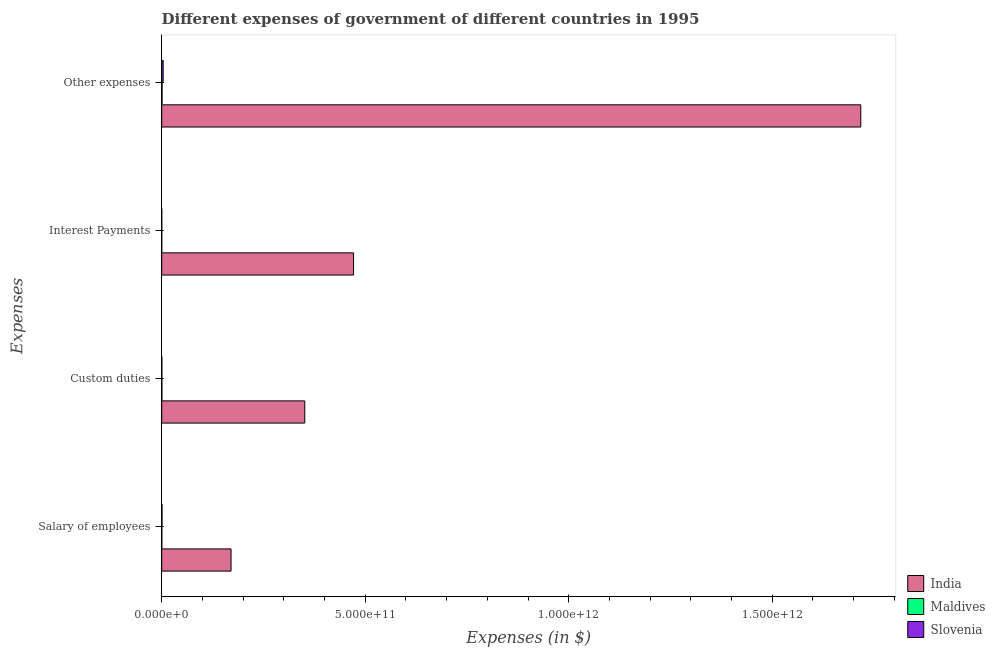How many different coloured bars are there?
Make the answer very short. 3. Are the number of bars on each tick of the Y-axis equal?
Offer a very short reply. Yes. How many bars are there on the 2nd tick from the top?
Your response must be concise. 3. How many bars are there on the 1st tick from the bottom?
Ensure brevity in your answer.  3. What is the label of the 3rd group of bars from the top?
Provide a succinct answer. Custom duties. What is the amount spent on other expenses in Maldives?
Keep it short and to the point. 8.78e+08. Across all countries, what is the maximum amount spent on interest payments?
Make the answer very short. 4.71e+11. Across all countries, what is the minimum amount spent on salary of employees?
Provide a succinct answer. 2.32e+08. In which country was the amount spent on interest payments minimum?
Give a very brief answer. Maldives. What is the total amount spent on other expenses in the graph?
Your answer should be very brief. 1.72e+12. What is the difference between the amount spent on interest payments in Slovenia and that in India?
Offer a very short reply. -4.71e+11. What is the difference between the amount spent on other expenses in India and the amount spent on interest payments in Maldives?
Provide a succinct answer. 1.72e+12. What is the average amount spent on custom duties per country?
Provide a short and direct response. 1.17e+11. What is the difference between the amount spent on salary of employees and amount spent on custom duties in Slovenia?
Your answer should be very brief. 4.04e+08. In how many countries, is the amount spent on other expenses greater than 1300000000000 $?
Provide a succinct answer. 1. What is the ratio of the amount spent on other expenses in Maldives to that in India?
Provide a short and direct response. 0. What is the difference between the highest and the second highest amount spent on salary of employees?
Give a very brief answer. 1.70e+11. What is the difference between the highest and the lowest amount spent on salary of employees?
Give a very brief answer. 1.70e+11. Is the sum of the amount spent on salary of employees in India and Slovenia greater than the maximum amount spent on interest payments across all countries?
Offer a very short reply. No. What does the 1st bar from the top in Salary of employees represents?
Make the answer very short. Slovenia. What does the 1st bar from the bottom in Custom duties represents?
Your answer should be compact. India. Is it the case that in every country, the sum of the amount spent on salary of employees and amount spent on custom duties is greater than the amount spent on interest payments?
Provide a succinct answer. Yes. How many bars are there?
Your answer should be very brief. 12. Are all the bars in the graph horizontal?
Offer a very short reply. Yes. What is the difference between two consecutive major ticks on the X-axis?
Your response must be concise. 5.00e+11. Does the graph contain any zero values?
Offer a terse response. No. Where does the legend appear in the graph?
Make the answer very short. Bottom right. How are the legend labels stacked?
Offer a terse response. Vertical. What is the title of the graph?
Keep it short and to the point. Different expenses of government of different countries in 1995. What is the label or title of the X-axis?
Make the answer very short. Expenses (in $). What is the label or title of the Y-axis?
Ensure brevity in your answer.  Expenses. What is the Expenses (in $) in India in Salary of employees?
Make the answer very short. 1.70e+11. What is the Expenses (in $) of Maldives in Salary of employees?
Your response must be concise. 2.32e+08. What is the Expenses (in $) in Slovenia in Salary of employees?
Provide a succinct answer. 7.30e+08. What is the Expenses (in $) in India in Custom duties?
Keep it short and to the point. 3.51e+11. What is the Expenses (in $) in Maldives in Custom duties?
Offer a terse response. 4.10e+08. What is the Expenses (in $) in Slovenia in Custom duties?
Make the answer very short. 3.26e+08. What is the Expenses (in $) in India in Interest Payments?
Your answer should be very brief. 4.71e+11. What is the Expenses (in $) in Maldives in Interest Payments?
Make the answer very short. 7.65e+07. What is the Expenses (in $) of Slovenia in Interest Payments?
Your answer should be compact. 1.04e+08. What is the Expenses (in $) of India in Other expenses?
Ensure brevity in your answer.  1.72e+12. What is the Expenses (in $) in Maldives in Other expenses?
Your response must be concise. 8.78e+08. What is the Expenses (in $) of Slovenia in Other expenses?
Provide a succinct answer. 3.53e+09. Across all Expenses, what is the maximum Expenses (in $) of India?
Give a very brief answer. 1.72e+12. Across all Expenses, what is the maximum Expenses (in $) of Maldives?
Make the answer very short. 8.78e+08. Across all Expenses, what is the maximum Expenses (in $) of Slovenia?
Provide a short and direct response. 3.53e+09. Across all Expenses, what is the minimum Expenses (in $) of India?
Give a very brief answer. 1.70e+11. Across all Expenses, what is the minimum Expenses (in $) of Maldives?
Give a very brief answer. 7.65e+07. Across all Expenses, what is the minimum Expenses (in $) of Slovenia?
Provide a short and direct response. 1.04e+08. What is the total Expenses (in $) of India in the graph?
Your answer should be compact. 2.71e+12. What is the total Expenses (in $) of Maldives in the graph?
Ensure brevity in your answer.  1.60e+09. What is the total Expenses (in $) in Slovenia in the graph?
Give a very brief answer. 4.69e+09. What is the difference between the Expenses (in $) of India in Salary of employees and that in Custom duties?
Keep it short and to the point. -1.81e+11. What is the difference between the Expenses (in $) in Maldives in Salary of employees and that in Custom duties?
Ensure brevity in your answer.  -1.78e+08. What is the difference between the Expenses (in $) of Slovenia in Salary of employees and that in Custom duties?
Make the answer very short. 4.04e+08. What is the difference between the Expenses (in $) in India in Salary of employees and that in Interest Payments?
Give a very brief answer. -3.01e+11. What is the difference between the Expenses (in $) in Maldives in Salary of employees and that in Interest Payments?
Offer a terse response. 1.56e+08. What is the difference between the Expenses (in $) of Slovenia in Salary of employees and that in Interest Payments?
Provide a short and direct response. 6.26e+08. What is the difference between the Expenses (in $) in India in Salary of employees and that in Other expenses?
Make the answer very short. -1.55e+12. What is the difference between the Expenses (in $) in Maldives in Salary of employees and that in Other expenses?
Give a very brief answer. -6.46e+08. What is the difference between the Expenses (in $) in Slovenia in Salary of employees and that in Other expenses?
Your response must be concise. -2.80e+09. What is the difference between the Expenses (in $) of India in Custom duties and that in Interest Payments?
Keep it short and to the point. -1.20e+11. What is the difference between the Expenses (in $) in Maldives in Custom duties and that in Interest Payments?
Offer a terse response. 3.34e+08. What is the difference between the Expenses (in $) in Slovenia in Custom duties and that in Interest Payments?
Your answer should be compact. 2.22e+08. What is the difference between the Expenses (in $) of India in Custom duties and that in Other expenses?
Offer a very short reply. -1.37e+12. What is the difference between the Expenses (in $) of Maldives in Custom duties and that in Other expenses?
Your answer should be very brief. -4.68e+08. What is the difference between the Expenses (in $) in Slovenia in Custom duties and that in Other expenses?
Make the answer very short. -3.21e+09. What is the difference between the Expenses (in $) in India in Interest Payments and that in Other expenses?
Give a very brief answer. -1.25e+12. What is the difference between the Expenses (in $) of Maldives in Interest Payments and that in Other expenses?
Give a very brief answer. -8.02e+08. What is the difference between the Expenses (in $) in Slovenia in Interest Payments and that in Other expenses?
Give a very brief answer. -3.43e+09. What is the difference between the Expenses (in $) in India in Salary of employees and the Expenses (in $) in Maldives in Custom duties?
Ensure brevity in your answer.  1.70e+11. What is the difference between the Expenses (in $) of India in Salary of employees and the Expenses (in $) of Slovenia in Custom duties?
Offer a very short reply. 1.70e+11. What is the difference between the Expenses (in $) in Maldives in Salary of employees and the Expenses (in $) in Slovenia in Custom duties?
Your answer should be very brief. -9.41e+07. What is the difference between the Expenses (in $) in India in Salary of employees and the Expenses (in $) in Maldives in Interest Payments?
Give a very brief answer. 1.70e+11. What is the difference between the Expenses (in $) of India in Salary of employees and the Expenses (in $) of Slovenia in Interest Payments?
Make the answer very short. 1.70e+11. What is the difference between the Expenses (in $) of Maldives in Salary of employees and the Expenses (in $) of Slovenia in Interest Payments?
Your response must be concise. 1.28e+08. What is the difference between the Expenses (in $) in India in Salary of employees and the Expenses (in $) in Maldives in Other expenses?
Your response must be concise. 1.69e+11. What is the difference between the Expenses (in $) in India in Salary of employees and the Expenses (in $) in Slovenia in Other expenses?
Give a very brief answer. 1.67e+11. What is the difference between the Expenses (in $) in Maldives in Salary of employees and the Expenses (in $) in Slovenia in Other expenses?
Offer a very short reply. -3.30e+09. What is the difference between the Expenses (in $) in India in Custom duties and the Expenses (in $) in Maldives in Interest Payments?
Give a very brief answer. 3.51e+11. What is the difference between the Expenses (in $) in India in Custom duties and the Expenses (in $) in Slovenia in Interest Payments?
Your response must be concise. 3.51e+11. What is the difference between the Expenses (in $) in Maldives in Custom duties and the Expenses (in $) in Slovenia in Interest Payments?
Your answer should be very brief. 3.06e+08. What is the difference between the Expenses (in $) in India in Custom duties and the Expenses (in $) in Maldives in Other expenses?
Your response must be concise. 3.51e+11. What is the difference between the Expenses (in $) of India in Custom duties and the Expenses (in $) of Slovenia in Other expenses?
Keep it short and to the point. 3.48e+11. What is the difference between the Expenses (in $) in Maldives in Custom duties and the Expenses (in $) in Slovenia in Other expenses?
Offer a very short reply. -3.12e+09. What is the difference between the Expenses (in $) in India in Interest Payments and the Expenses (in $) in Maldives in Other expenses?
Give a very brief answer. 4.70e+11. What is the difference between the Expenses (in $) of India in Interest Payments and the Expenses (in $) of Slovenia in Other expenses?
Offer a very short reply. 4.68e+11. What is the difference between the Expenses (in $) of Maldives in Interest Payments and the Expenses (in $) of Slovenia in Other expenses?
Give a very brief answer. -3.46e+09. What is the average Expenses (in $) of India per Expenses?
Offer a terse response. 6.78e+11. What is the average Expenses (in $) in Maldives per Expenses?
Your answer should be very brief. 3.99e+08. What is the average Expenses (in $) of Slovenia per Expenses?
Offer a terse response. 1.17e+09. What is the difference between the Expenses (in $) in India and Expenses (in $) in Maldives in Salary of employees?
Make the answer very short. 1.70e+11. What is the difference between the Expenses (in $) of India and Expenses (in $) of Slovenia in Salary of employees?
Make the answer very short. 1.70e+11. What is the difference between the Expenses (in $) of Maldives and Expenses (in $) of Slovenia in Salary of employees?
Provide a succinct answer. -4.98e+08. What is the difference between the Expenses (in $) in India and Expenses (in $) in Maldives in Custom duties?
Offer a terse response. 3.51e+11. What is the difference between the Expenses (in $) of India and Expenses (in $) of Slovenia in Custom duties?
Provide a short and direct response. 3.51e+11. What is the difference between the Expenses (in $) of Maldives and Expenses (in $) of Slovenia in Custom duties?
Your answer should be very brief. 8.37e+07. What is the difference between the Expenses (in $) of India and Expenses (in $) of Maldives in Interest Payments?
Give a very brief answer. 4.71e+11. What is the difference between the Expenses (in $) in India and Expenses (in $) in Slovenia in Interest Payments?
Your answer should be compact. 4.71e+11. What is the difference between the Expenses (in $) in Maldives and Expenses (in $) in Slovenia in Interest Payments?
Your answer should be compact. -2.78e+07. What is the difference between the Expenses (in $) in India and Expenses (in $) in Maldives in Other expenses?
Ensure brevity in your answer.  1.72e+12. What is the difference between the Expenses (in $) in India and Expenses (in $) in Slovenia in Other expenses?
Your response must be concise. 1.71e+12. What is the difference between the Expenses (in $) in Maldives and Expenses (in $) in Slovenia in Other expenses?
Your answer should be compact. -2.66e+09. What is the ratio of the Expenses (in $) of India in Salary of employees to that in Custom duties?
Your answer should be very brief. 0.48. What is the ratio of the Expenses (in $) in Maldives in Salary of employees to that in Custom duties?
Offer a very short reply. 0.57. What is the ratio of the Expenses (in $) of Slovenia in Salary of employees to that in Custom duties?
Make the answer very short. 2.24. What is the ratio of the Expenses (in $) in India in Salary of employees to that in Interest Payments?
Keep it short and to the point. 0.36. What is the ratio of the Expenses (in $) in Maldives in Salary of employees to that in Interest Payments?
Make the answer very short. 3.04. What is the ratio of the Expenses (in $) in Slovenia in Salary of employees to that in Interest Payments?
Your response must be concise. 7. What is the ratio of the Expenses (in $) in India in Salary of employees to that in Other expenses?
Your response must be concise. 0.1. What is the ratio of the Expenses (in $) of Maldives in Salary of employees to that in Other expenses?
Your response must be concise. 0.26. What is the ratio of the Expenses (in $) in Slovenia in Salary of employees to that in Other expenses?
Offer a very short reply. 0.21. What is the ratio of the Expenses (in $) of India in Custom duties to that in Interest Payments?
Your answer should be very brief. 0.75. What is the ratio of the Expenses (in $) in Maldives in Custom duties to that in Interest Payments?
Provide a short and direct response. 5.36. What is the ratio of the Expenses (in $) in Slovenia in Custom duties to that in Interest Payments?
Your answer should be very brief. 3.13. What is the ratio of the Expenses (in $) of India in Custom duties to that in Other expenses?
Your answer should be compact. 0.2. What is the ratio of the Expenses (in $) in Maldives in Custom duties to that in Other expenses?
Ensure brevity in your answer.  0.47. What is the ratio of the Expenses (in $) in Slovenia in Custom duties to that in Other expenses?
Your answer should be compact. 0.09. What is the ratio of the Expenses (in $) of India in Interest Payments to that in Other expenses?
Make the answer very short. 0.27. What is the ratio of the Expenses (in $) of Maldives in Interest Payments to that in Other expenses?
Keep it short and to the point. 0.09. What is the ratio of the Expenses (in $) of Slovenia in Interest Payments to that in Other expenses?
Give a very brief answer. 0.03. What is the difference between the highest and the second highest Expenses (in $) of India?
Offer a terse response. 1.25e+12. What is the difference between the highest and the second highest Expenses (in $) in Maldives?
Your response must be concise. 4.68e+08. What is the difference between the highest and the second highest Expenses (in $) in Slovenia?
Make the answer very short. 2.80e+09. What is the difference between the highest and the lowest Expenses (in $) of India?
Your response must be concise. 1.55e+12. What is the difference between the highest and the lowest Expenses (in $) in Maldives?
Your answer should be very brief. 8.02e+08. What is the difference between the highest and the lowest Expenses (in $) in Slovenia?
Keep it short and to the point. 3.43e+09. 